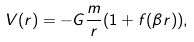<formula> <loc_0><loc_0><loc_500><loc_500>V ( r ) = - G \frac { m } { r } ( 1 + f ( \beta r ) ) ,</formula> 